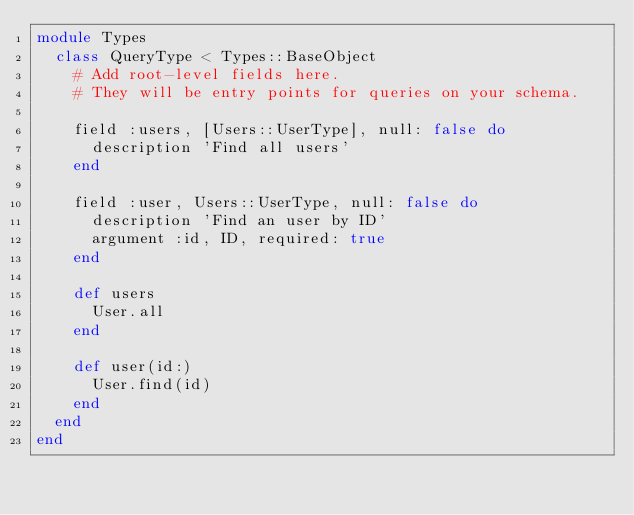<code> <loc_0><loc_0><loc_500><loc_500><_Ruby_>module Types
  class QueryType < Types::BaseObject
    # Add root-level fields here.
    # They will be entry points for queries on your schema.

    field :users, [Users::UserType], null: false do
      description 'Find all users'
    end

    field :user, Users::UserType, null: false do
      description 'Find an user by ID'
      argument :id, ID, required: true
    end

    def users
      User.all
    end

    def user(id:)
      User.find(id)
    end
  end
end
</code> 